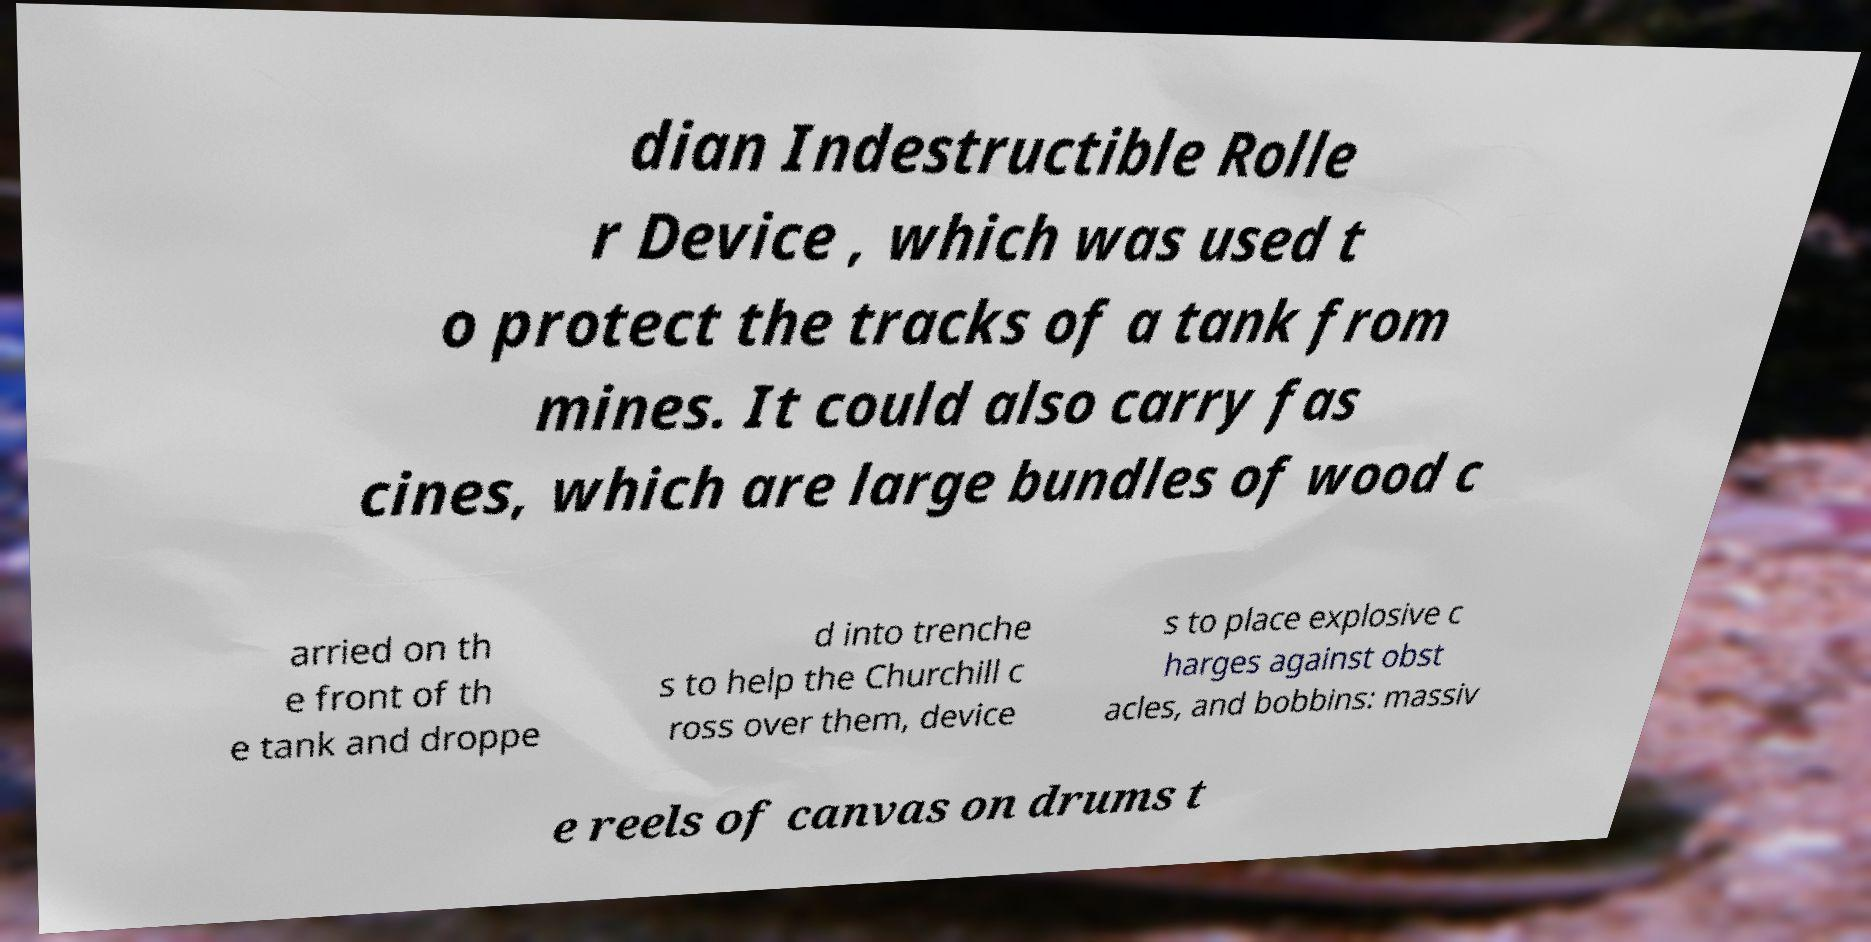Can you accurately transcribe the text from the provided image for me? dian Indestructible Rolle r Device , which was used t o protect the tracks of a tank from mines. It could also carry fas cines, which are large bundles of wood c arried on th e front of th e tank and droppe d into trenche s to help the Churchill c ross over them, device s to place explosive c harges against obst acles, and bobbins: massiv e reels of canvas on drums t 